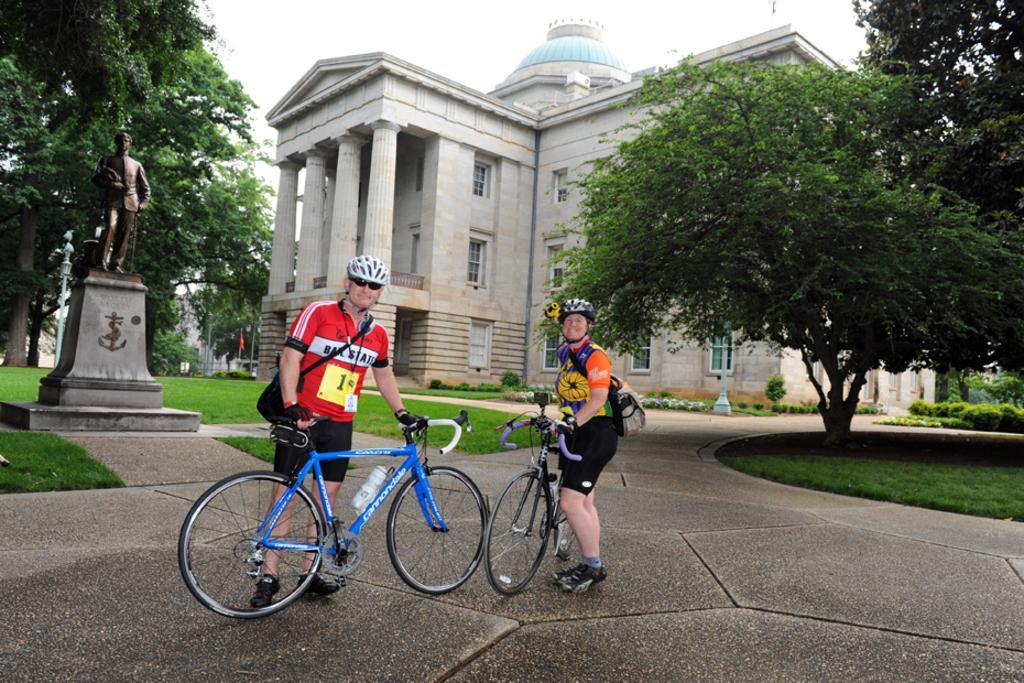Describe this image in one or two sentences. In this image, in the middle, we can see two people wearing backpack and staining on the road and also holding bicycles in their hand. On the right side, we can see some trees and plants. On the left side, we can see a statue, trees and plants. In the background, we can see a building, pillars, window, plants, pole, flag. At the top, we can see a sky, at the bottom, we can see a grass and a land. 